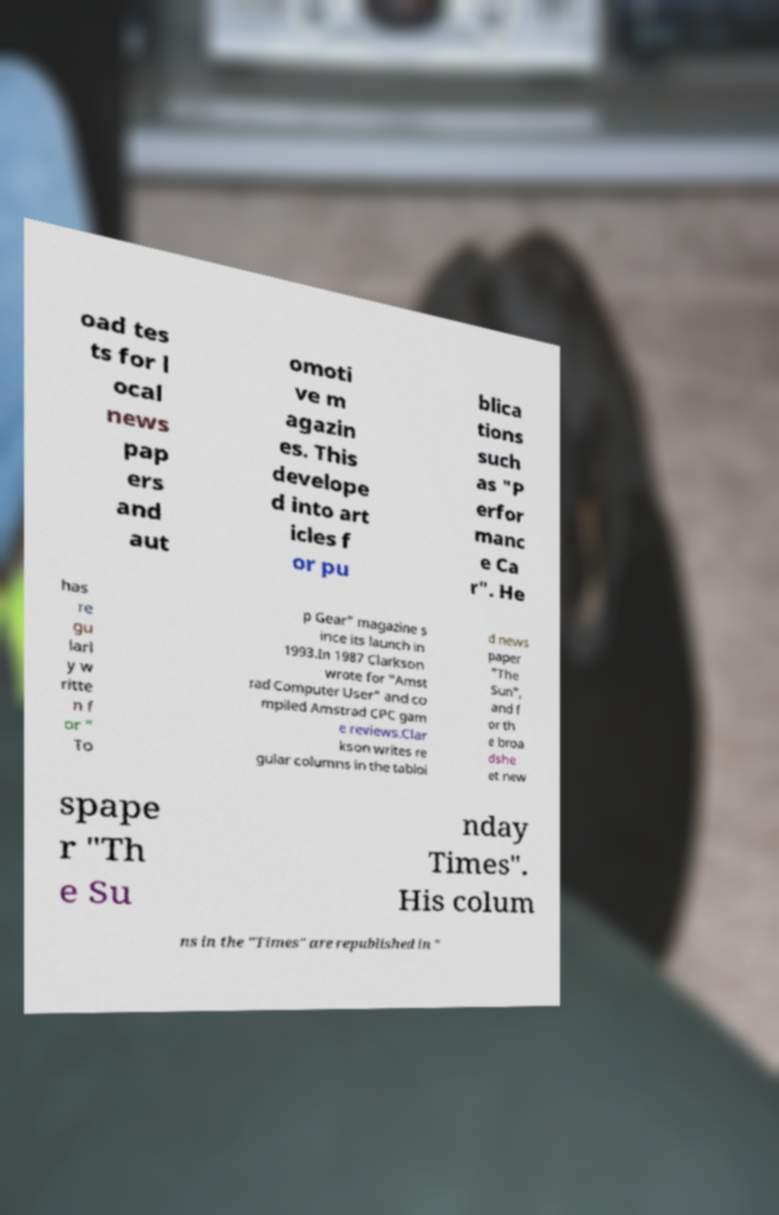Could you extract and type out the text from this image? oad tes ts for l ocal news pap ers and aut omoti ve m agazin es. This develope d into art icles f or pu blica tions such as "P erfor manc e Ca r". He has re gu larl y w ritte n f or " To p Gear" magazine s ince its launch in 1993.In 1987 Clarkson wrote for "Amst rad Computer User" and co mpiled Amstrad CPC gam e reviews.Clar kson writes re gular columns in the tabloi d news paper "The Sun", and f or th e broa dshe et new spape r "Th e Su nday Times". His colum ns in the "Times" are republished in " 